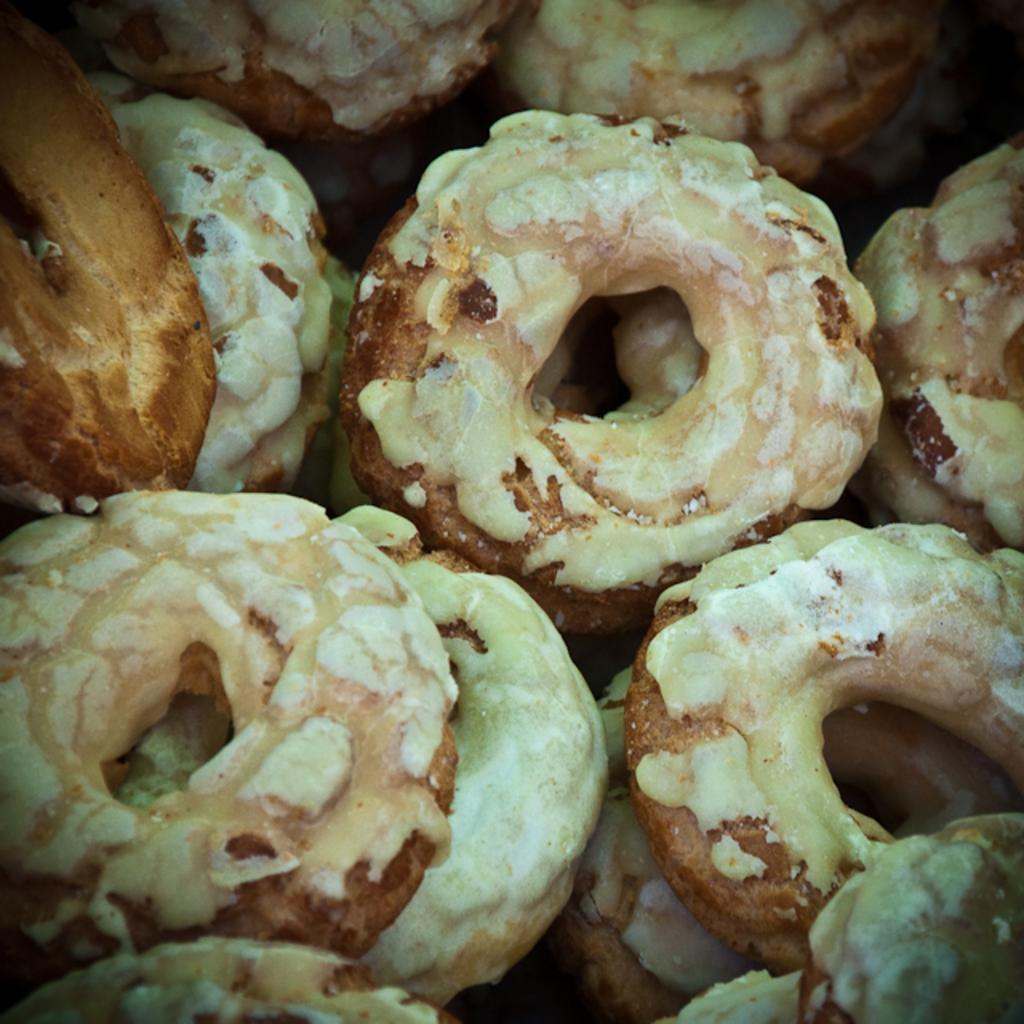In one or two sentences, can you explain what this image depicts? In this picture we can see some doughnuts. 